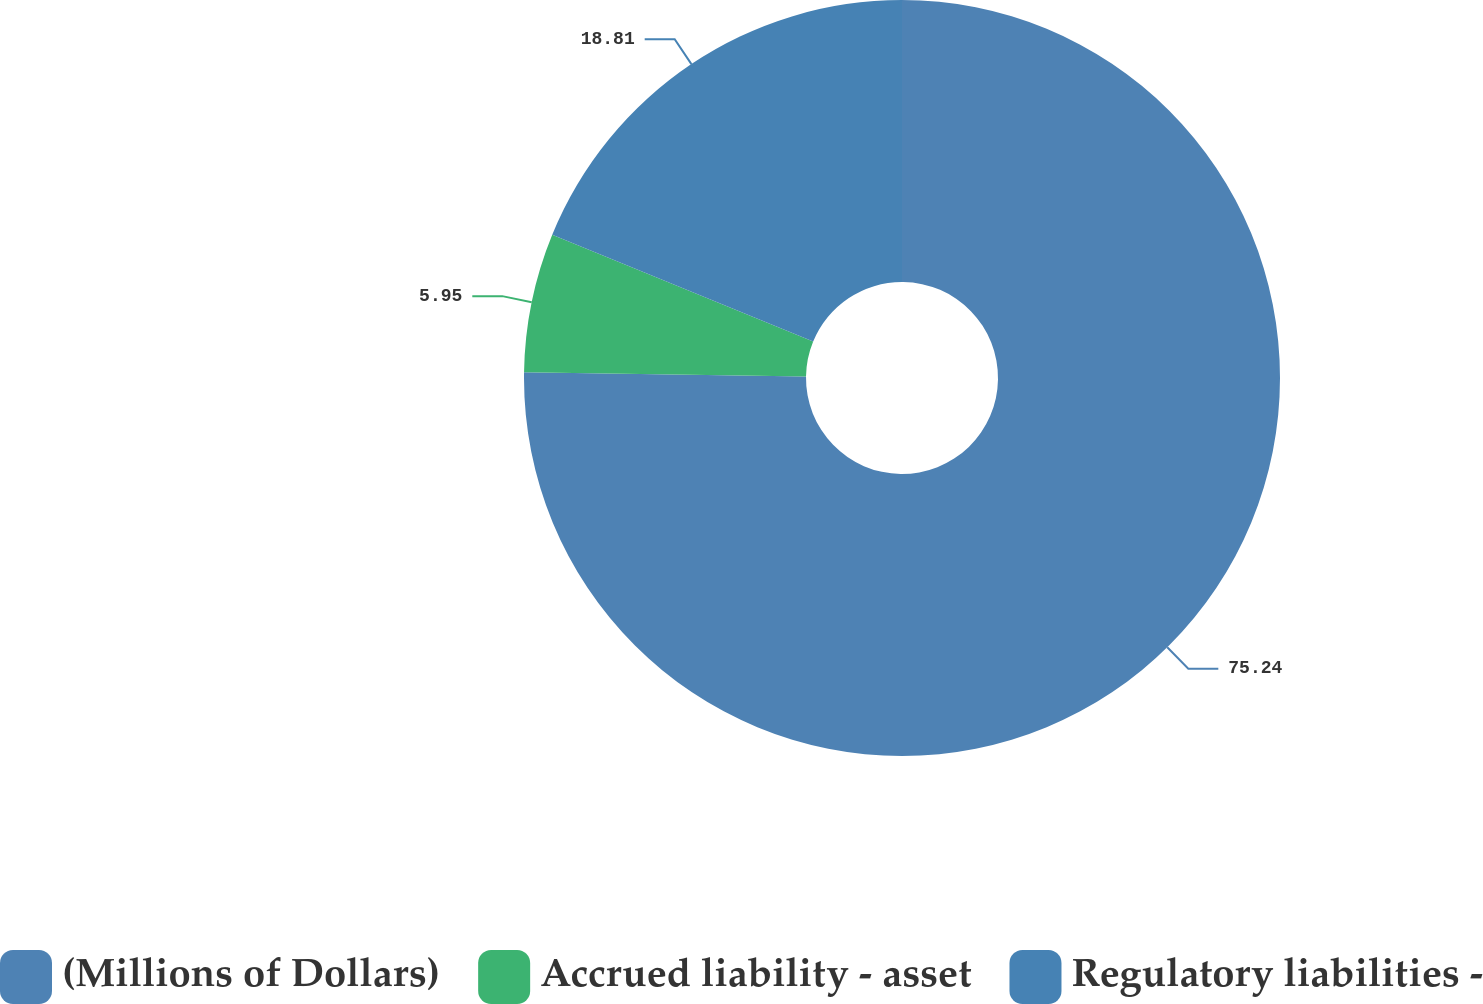<chart> <loc_0><loc_0><loc_500><loc_500><pie_chart><fcel>(Millions of Dollars)<fcel>Accrued liability - asset<fcel>Regulatory liabilities -<nl><fcel>75.24%<fcel>5.95%<fcel>18.81%<nl></chart> 